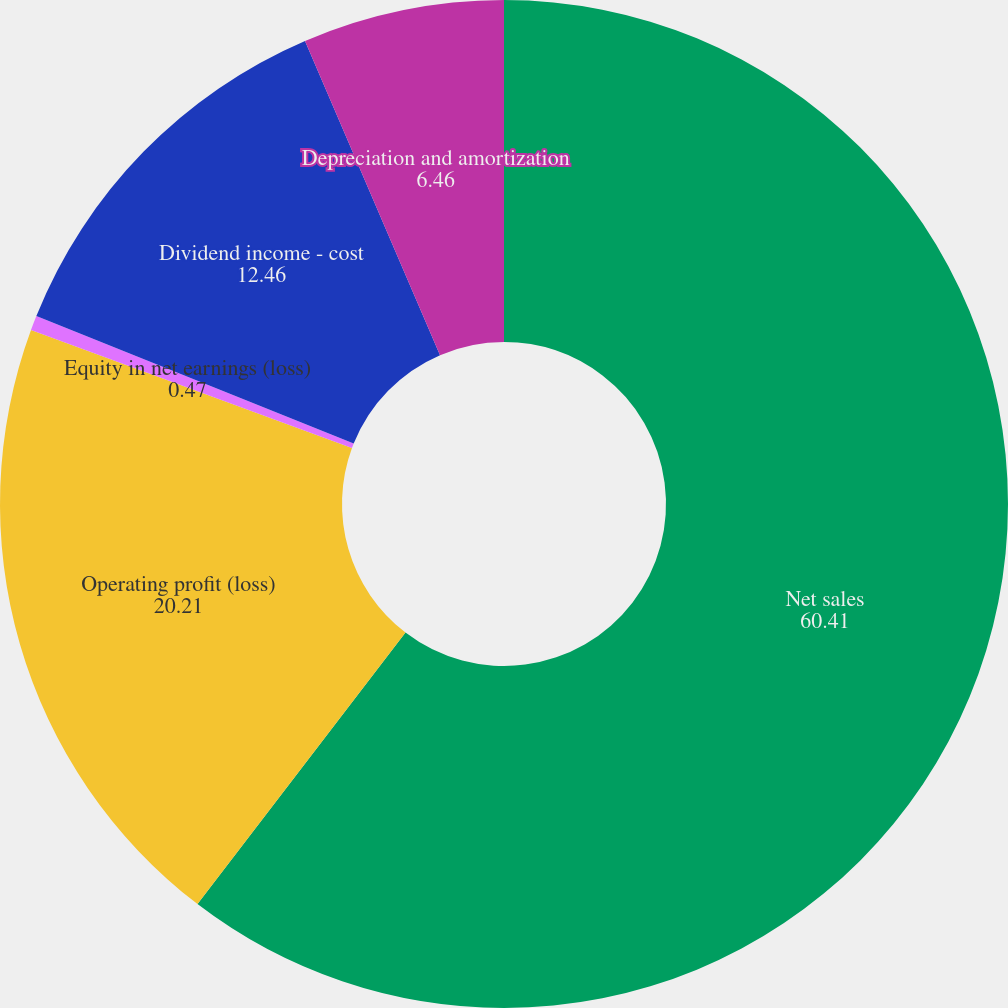<chart> <loc_0><loc_0><loc_500><loc_500><pie_chart><fcel>Net sales<fcel>Operating profit (loss)<fcel>Equity in net earnings (loss)<fcel>Dividend income - cost<fcel>Depreciation and amortization<nl><fcel>60.41%<fcel>20.21%<fcel>0.47%<fcel>12.46%<fcel>6.46%<nl></chart> 